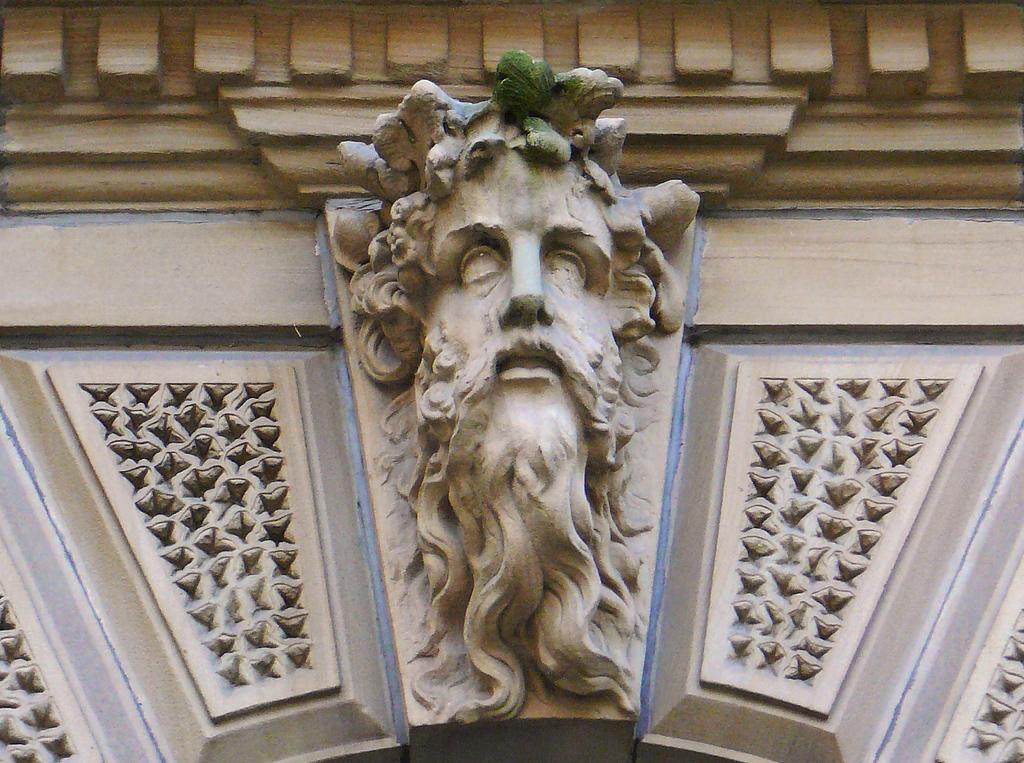What is the main subject of the image? There is a sculpture of a person with a beard in the image. Where is the sculpture located in the image? The sculpture is in the center of the image. How is the sculpture attached to the building? The sculpture is attached to the wall of a building. What type of scissors can be seen cutting the corn in the image? There are no scissors or corn present in the image; it features a sculpture of a person with a beard. 